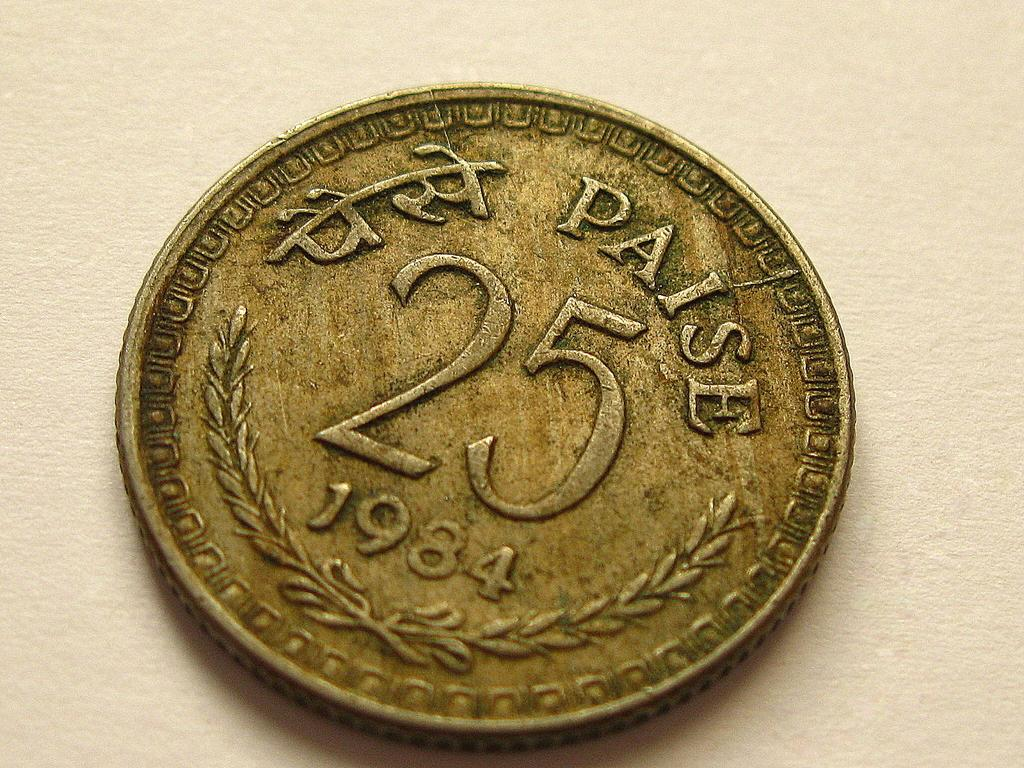Provide a one-sentence caption for the provided image. A dirty coin that says 25 Paise with the date 1984. 